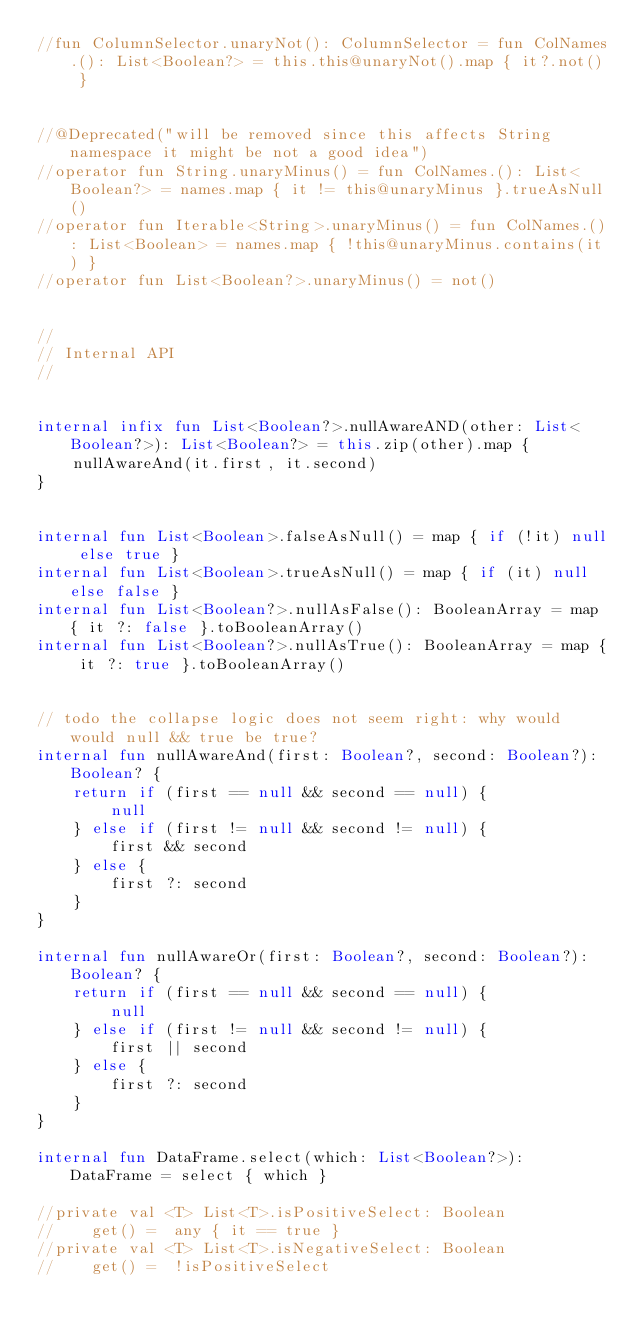Convert code to text. <code><loc_0><loc_0><loc_500><loc_500><_Kotlin_>//fun ColumnSelector.unaryNot(): ColumnSelector = fun ColNames.(): List<Boolean?> = this.this@unaryNot().map { it?.not() }


//@Deprecated("will be removed since this affects String namespace it might be not a good idea")
//operator fun String.unaryMinus() = fun ColNames.(): List<Boolean?> = names.map { it != this@unaryMinus }.trueAsNull()
//operator fun Iterable<String>.unaryMinus() = fun ColNames.(): List<Boolean> = names.map { !this@unaryMinus.contains(it) }
//operator fun List<Boolean?>.unaryMinus() = not()


//
// Internal API
//


internal infix fun List<Boolean?>.nullAwareAND(other: List<Boolean?>): List<Boolean?> = this.zip(other).map {
    nullAwareAnd(it.first, it.second)
}


internal fun List<Boolean>.falseAsNull() = map { if (!it) null else true }
internal fun List<Boolean>.trueAsNull() = map { if (it) null else false }
internal fun List<Boolean?>.nullAsFalse(): BooleanArray = map { it ?: false }.toBooleanArray()
internal fun List<Boolean?>.nullAsTrue(): BooleanArray = map { it ?: true }.toBooleanArray()


// todo the collapse logic does not seem right: why would would null && true be true?
internal fun nullAwareAnd(first: Boolean?, second: Boolean?): Boolean? {
    return if (first == null && second == null) {
        null
    } else if (first != null && second != null) {
        first && second
    } else {
        first ?: second
    }
}

internal fun nullAwareOr(first: Boolean?, second: Boolean?): Boolean? {
    return if (first == null && second == null) {
        null
    } else if (first != null && second != null) {
        first || second
    } else {
        first ?: second
    }
}

internal fun DataFrame.select(which: List<Boolean?>): DataFrame = select { which }

//private val <T> List<T>.isPositiveSelect: Boolean
//    get() =  any { it == true }
//private val <T> List<T>.isNegativeSelect: Boolean
//    get() =  !isPositiveSelect
</code> 